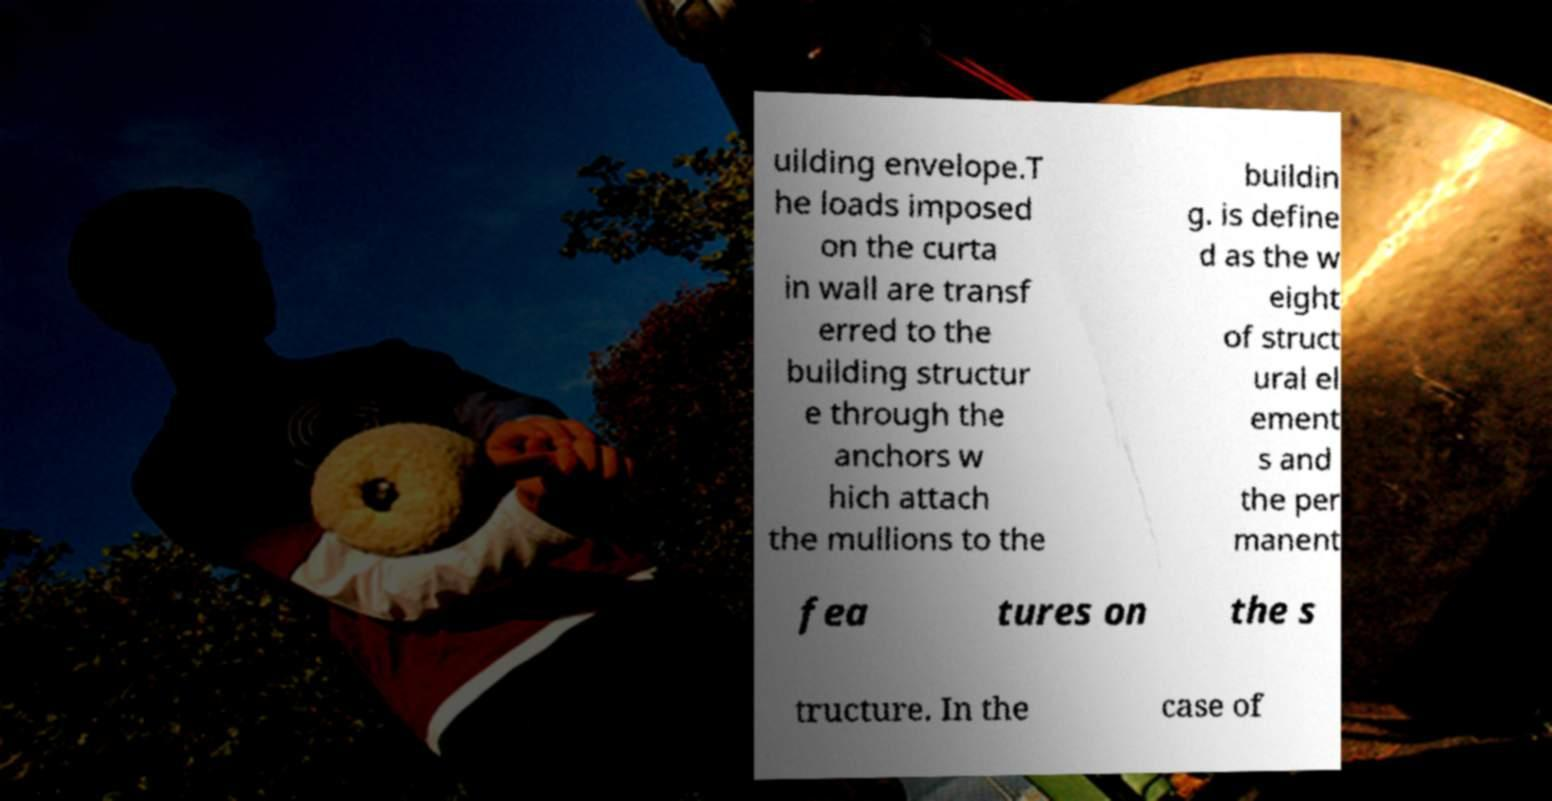There's text embedded in this image that I need extracted. Can you transcribe it verbatim? uilding envelope.T he loads imposed on the curta in wall are transf erred to the building structur e through the anchors w hich attach the mullions to the buildin g. is define d as the w eight of struct ural el ement s and the per manent fea tures on the s tructure. In the case of 